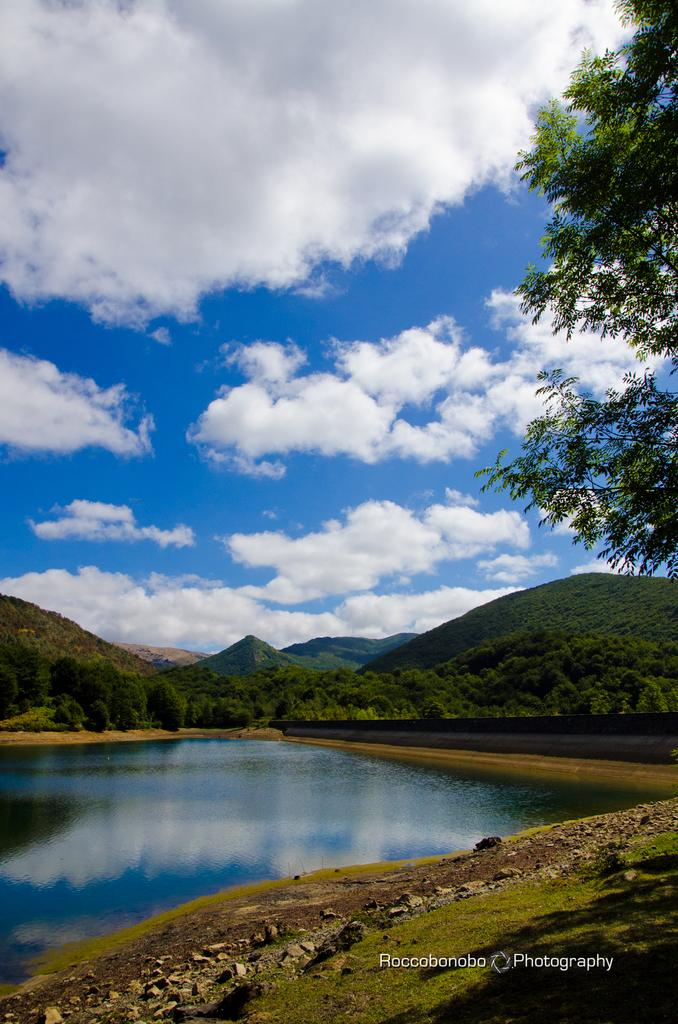What type of scenery is shown in the image? The image depicts a beautiful scenery. What is the main feature of the scenery? There is a water surface in the image. What surrounds the water surface? There are mountains around the water surface. Are there any plants visible in the image? Yes, there are trees in the image. Where is the drawer located in the image? There is no drawer present in the image. Can you see any ducks swimming in the water surface? There are no ducks visible in the image. 